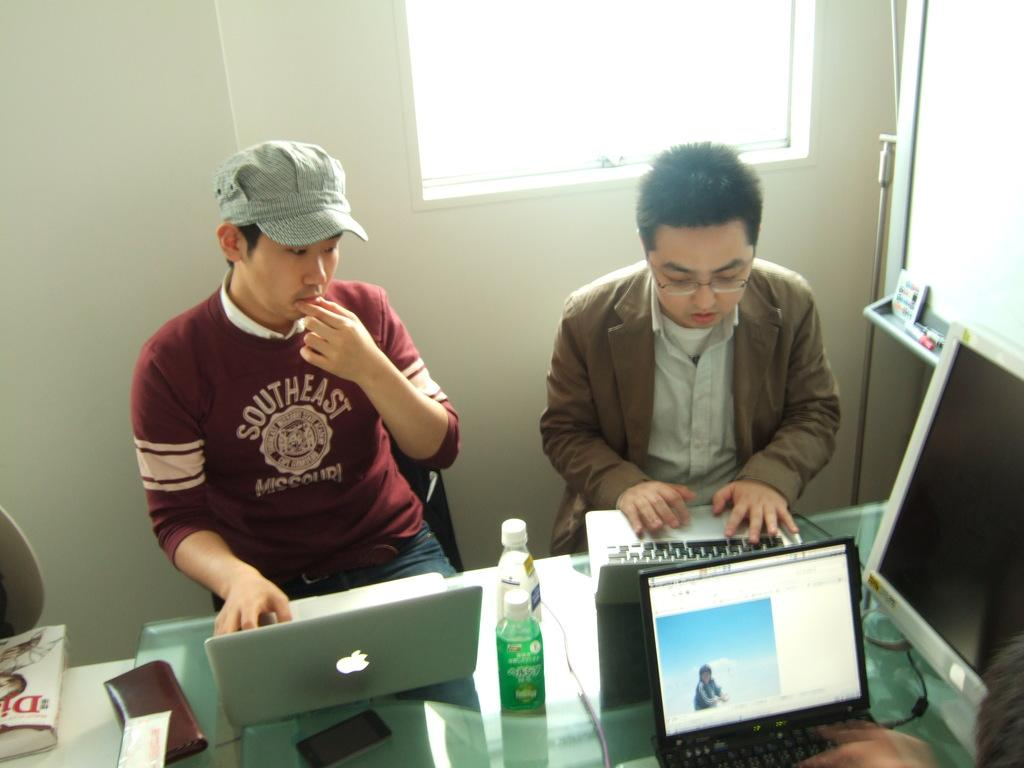How many people are in the image? There are two men in the image. What are the men doing in the image? The men are sitting and working on a laptop. What else can be seen in the image besides the men and the laptop? There are two bottles and a book on a table in the image. What can be seen in the background of the image? There is a wall and a window in the background of the image. What type of glass is being used to join the two men together in the image? There is no glass or any object being used to join the two men together in the image; they are simply sitting and working on a laptop. 